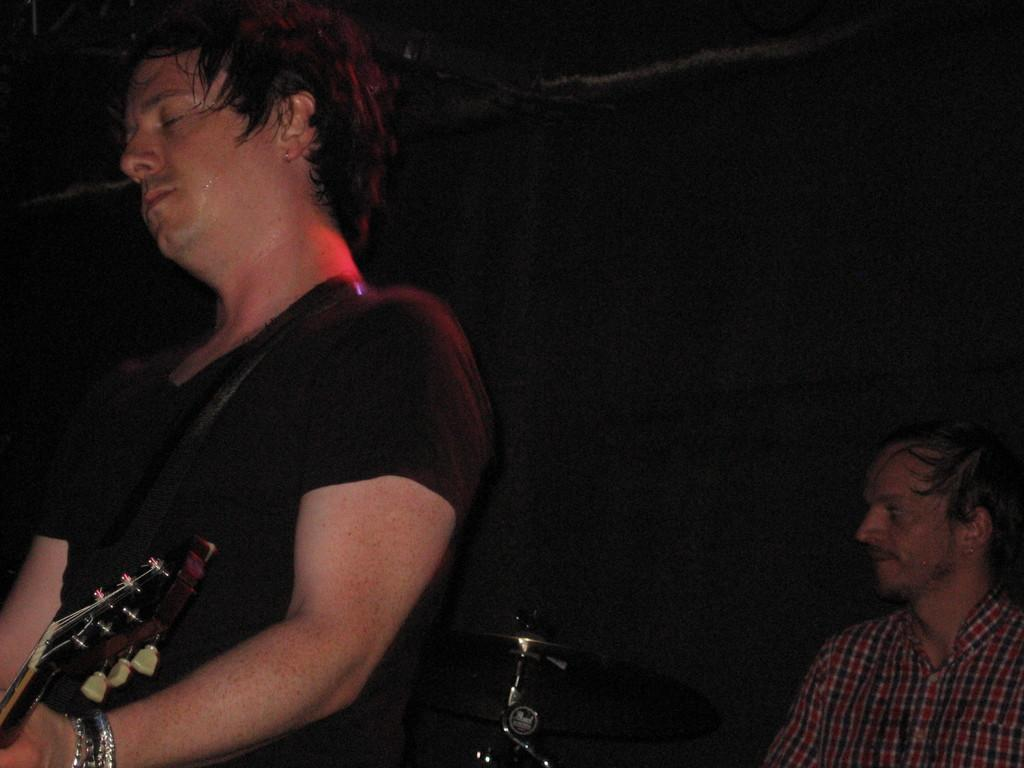What is the man in the image holding? The man is holding a guitar in the image. Can you describe the position of the person in the image? There is a person sitting on a chair in the image. What type of object is related to music in the image? A musical instrument, the guitar, is visible in the image. What type of letter is the man holding in the image? The man is not holding a letter in the image; he is holding a guitar. Can you describe the turkey that is present in the image? There is no turkey present in the image. 